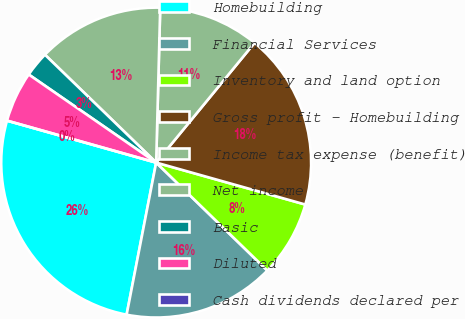Convert chart. <chart><loc_0><loc_0><loc_500><loc_500><pie_chart><fcel>Homebuilding<fcel>Financial Services<fcel>Inventory and land option<fcel>Gross profit - Homebuilding<fcel>Income tax expense (benefit)<fcel>Net income<fcel>Basic<fcel>Diluted<fcel>Cash dividends declared per<nl><fcel>26.31%<fcel>15.79%<fcel>7.9%<fcel>18.42%<fcel>10.53%<fcel>13.16%<fcel>2.63%<fcel>5.26%<fcel>0.0%<nl></chart> 